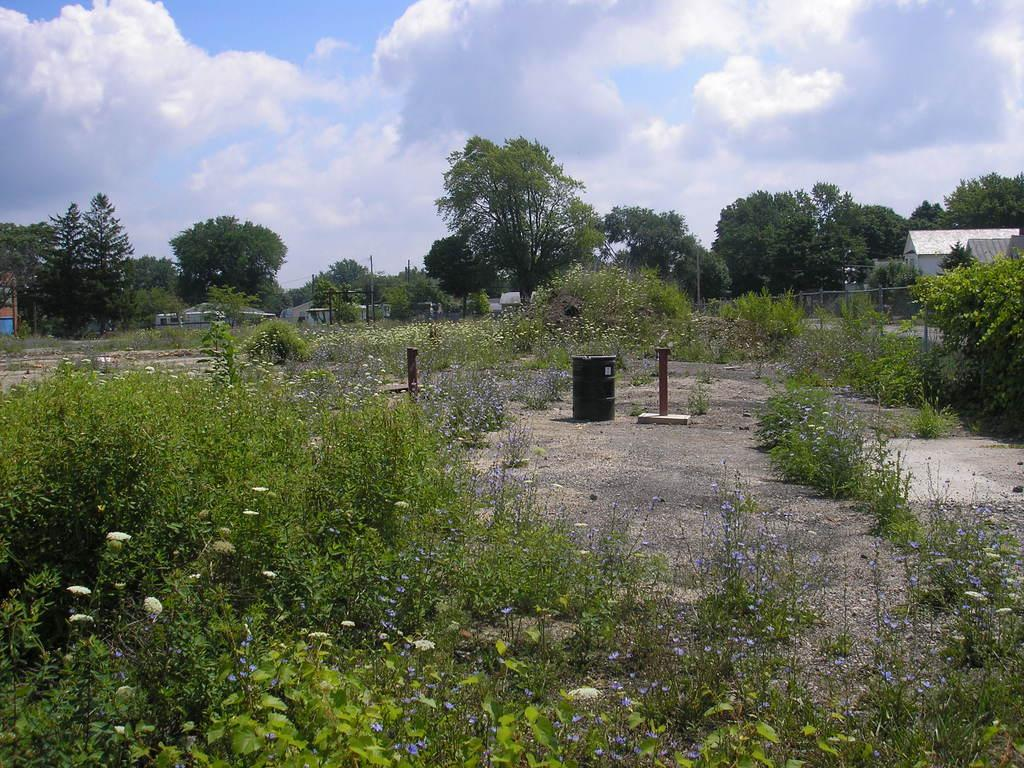What type of container is present in the image? There is a bin in the image. What are the two vertical structures on the ground in the image? There are two poles on the ground in the image. What type of natural elements can be seen in the image? There are flowers, plants, trees, and clouds in the image. What type of structures are visible in the image? There are houses and a fence in the image. What is visible in the background of the image? The sky is visible in the background of the image, with clouds present. How many pizzas are being held by the trees in the image? There are no pizzas present in the image; it features trees, flowers, plants, and other natural elements. What type of ear is visible on the fence in the image? There is no ear visible on the fence in the image; it is a solid structure with no ears or other human-like features. 